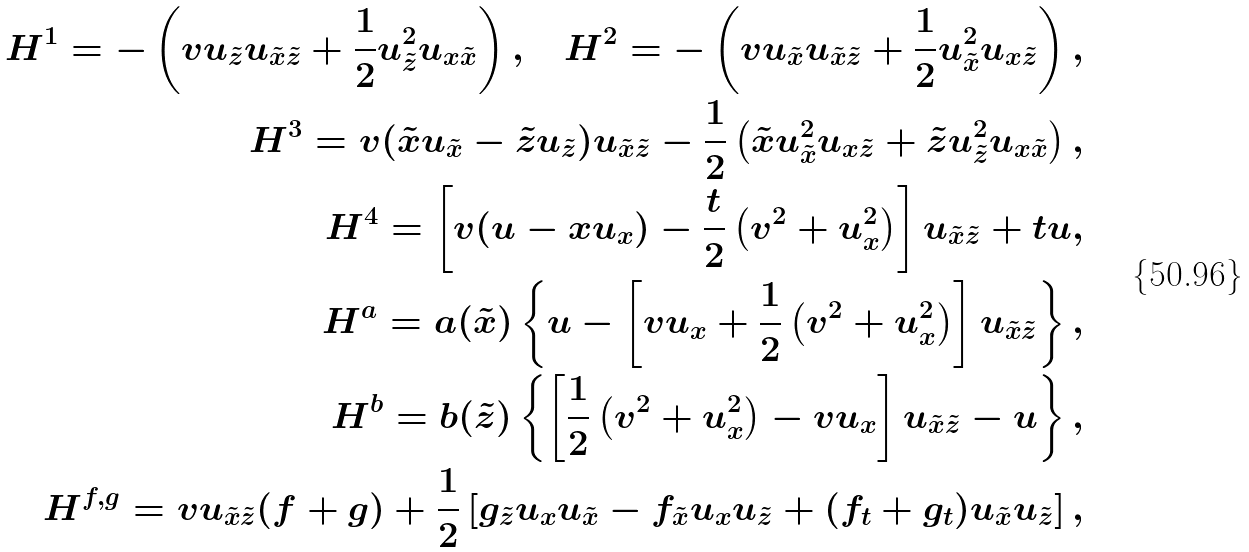Convert formula to latex. <formula><loc_0><loc_0><loc_500><loc_500>H ^ { 1 } = - \left ( v u _ { \tilde { z } } u _ { \tilde { x } \tilde { z } } + \frac { 1 } { 2 } u _ { \tilde { z } } ^ { 2 } u _ { x \tilde { x } } \right ) , \quad H ^ { 2 } = - \left ( v u _ { \tilde { x } } u _ { \tilde { x } \tilde { z } } + \frac { 1 } { 2 } u _ { \tilde { x } } ^ { 2 } u _ { x \tilde { z } } \right ) , \\ H ^ { 3 } = v ( \tilde { x } u _ { \tilde { x } } - \tilde { z } u _ { \tilde { z } } ) u _ { \tilde { x } \tilde { z } } - \frac { 1 } { 2 } \left ( \tilde { x } u _ { \tilde { x } } ^ { 2 } u _ { x \tilde { z } } + \tilde { z } u _ { \tilde { z } } ^ { 2 } u _ { x \tilde { x } } \right ) , \\ H ^ { 4 } = \left [ v ( u - x u _ { x } ) - \frac { t } { 2 } \left ( v ^ { 2 } + u _ { x } ^ { 2 } \right ) \right ] u _ { \tilde { x } \tilde { z } } + t u , \\ H ^ { a } = a ( \tilde { x } ) \left \{ u - \left [ v u _ { x } + \frac { 1 } { 2 } \left ( v ^ { 2 } + u _ { x } ^ { 2 } \right ) \right ] u _ { \tilde { x } \tilde { z } } \right \} , \\ H ^ { b } = b ( \tilde { z } ) \left \{ \left [ \frac { 1 } { 2 } \left ( v ^ { 2 } + u _ { x } ^ { 2 } \right ) - v u _ { x } \right ] u _ { \tilde { x } \tilde { z } } - u \right \} , \\ H ^ { f , g } = v u _ { \tilde { x } \tilde { z } } ( f + g ) + \frac { 1 } { 2 } \left [ g _ { \tilde { z } } u _ { x } u _ { \tilde { x } } - f _ { \tilde { x } } u _ { x } u _ { \tilde { z } } + ( f _ { t } + g _ { t } ) u _ { \tilde { x } } u _ { \tilde { z } } \right ] ,</formula> 